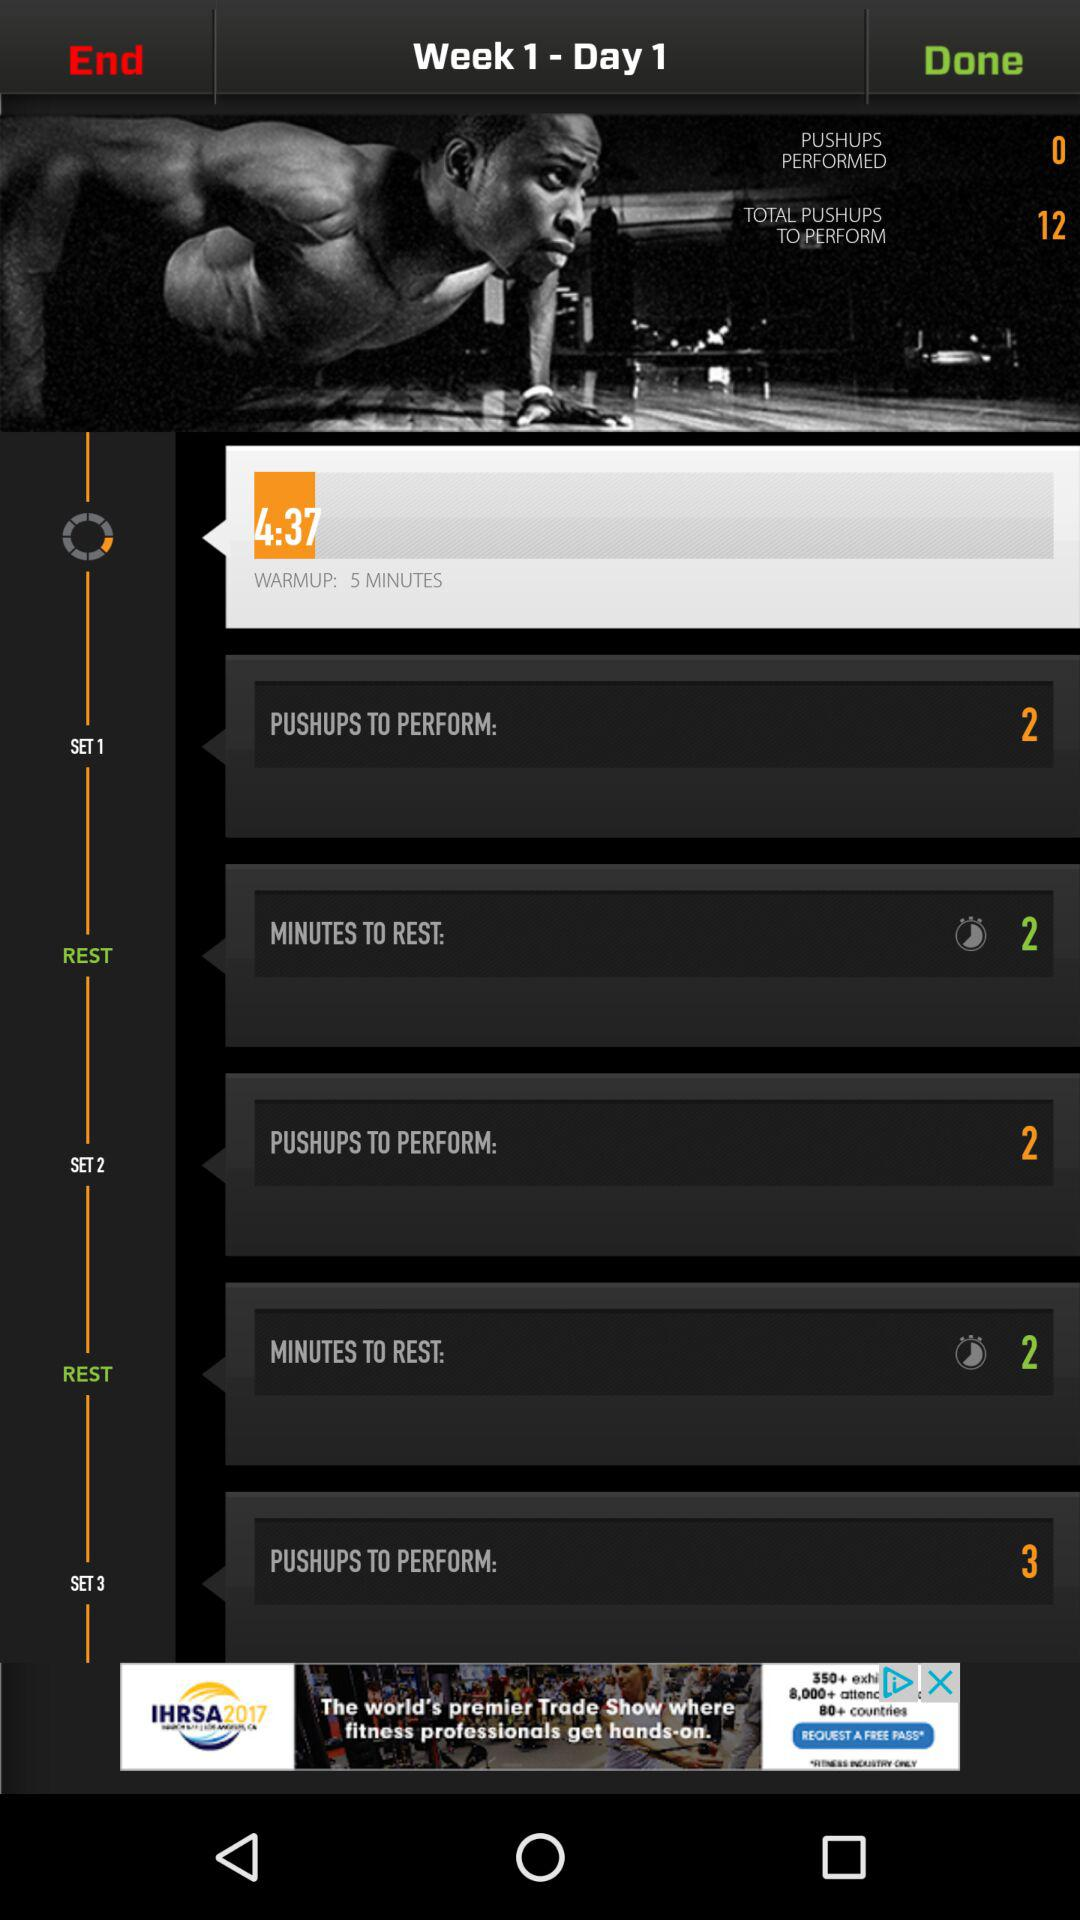What task is to be performed in set 2? The task to be performed in set 2 is 2 push-ups. 